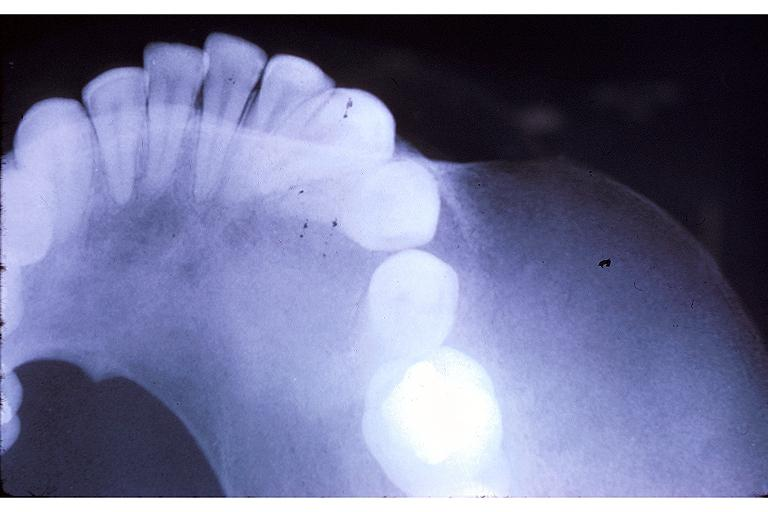what is present?
Answer the question using a single word or phrase. Oral 